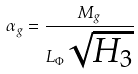<formula> <loc_0><loc_0><loc_500><loc_500>\alpha _ { g } = \frac { M _ { g } } { L _ { \Phi } \sqrt { H _ { 3 } } }</formula> 